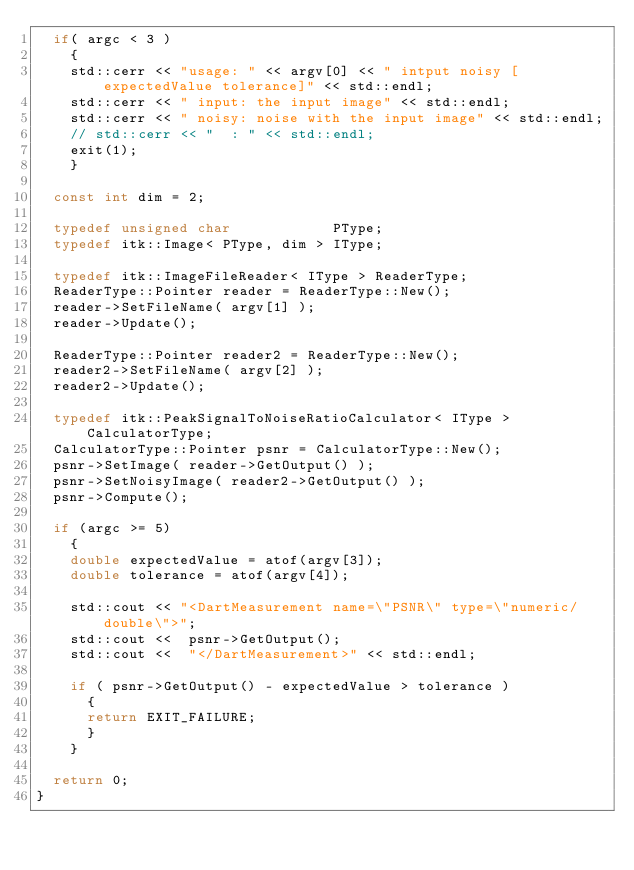Convert code to text. <code><loc_0><loc_0><loc_500><loc_500><_C++_>  if( argc < 3 )
    {
    std::cerr << "usage: " << argv[0] << " intput noisy [expectedValue tolerance]" << std::endl;
    std::cerr << " input: the input image" << std::endl;
    std::cerr << " noisy: noise with the input image" << std::endl;
    // std::cerr << "  : " << std::endl;
    exit(1);
    }

  const int dim = 2;

  typedef unsigned char            PType;
  typedef itk::Image< PType, dim > IType;

  typedef itk::ImageFileReader< IType > ReaderType;
  ReaderType::Pointer reader = ReaderType::New();
  reader->SetFileName( argv[1] );
  reader->Update();

  ReaderType::Pointer reader2 = ReaderType::New();
  reader2->SetFileName( argv[2] );
  reader2->Update();

  typedef itk::PeakSignalToNoiseRatioCalculator< IType > CalculatorType;
  CalculatorType::Pointer psnr = CalculatorType::New();
  psnr->SetImage( reader->GetOutput() );
  psnr->SetNoisyImage( reader2->GetOutput() );
  psnr->Compute();

  if (argc >= 5)
    {
    double expectedValue = atof(argv[3]);
    double tolerance = atof(argv[4]);

    std::cout << "<DartMeasurement name=\"PSNR\" type=\"numeric/double\">";
    std::cout <<  psnr->GetOutput();
    std::cout <<  "</DartMeasurement>" << std::endl;

    if ( psnr->GetOutput() - expectedValue > tolerance )
      {
      return EXIT_FAILURE;
      }
    }

  return 0;
}
</code> 